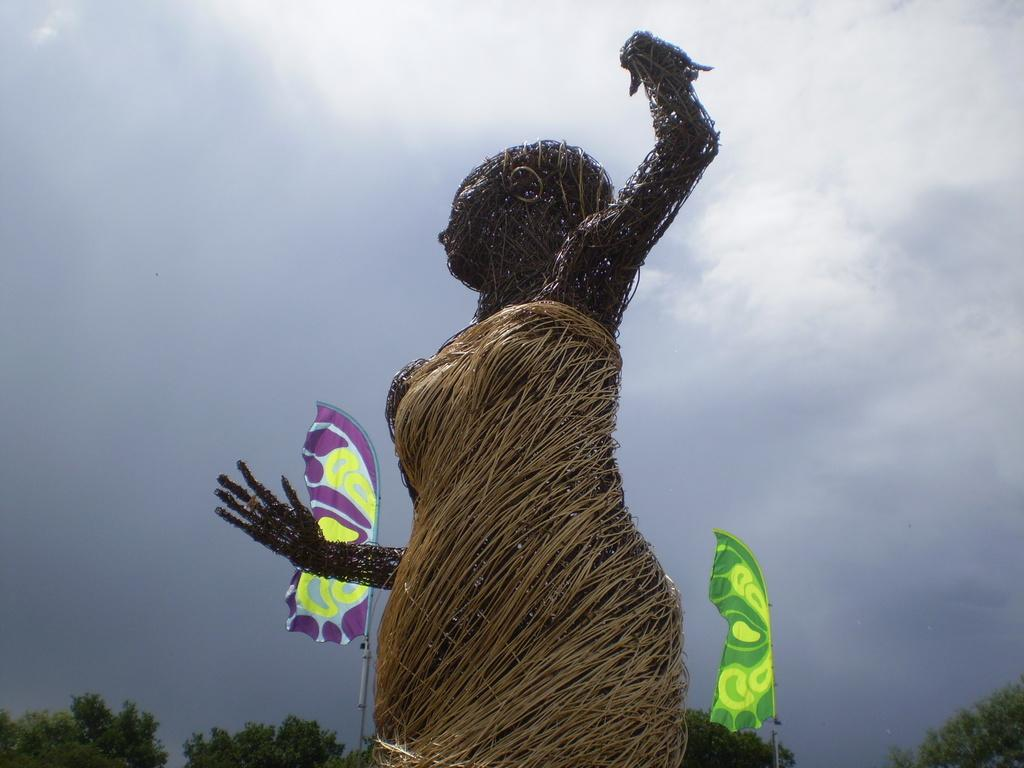What is the main subject in the image? There is a statue in the image. What can be seen in the background of the image? There are flags and trees in the background of the image. How would you describe the sky in the image? The sky is cloudy in the image. How many rays of sunlight can be seen shining on the statue in the image? There are no rays of sunlight visible in the image, as the sky is cloudy. What type of spy equipment is hidden in the statue in the image? There is no spy equipment present in the image; it features a statue with flags and trees in the background. 